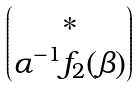<formula> <loc_0><loc_0><loc_500><loc_500>\begin{pmatrix} * \\ \alpha ^ { - 1 } f _ { 2 } ( \beta ) \end{pmatrix}</formula> 